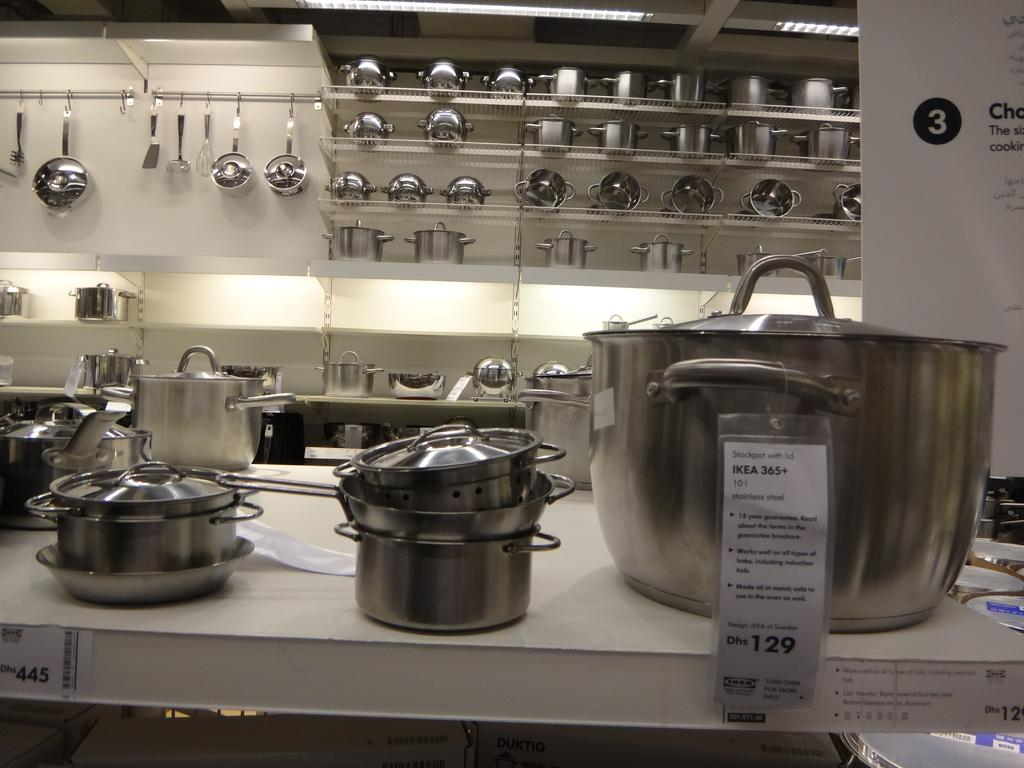Provide a one-sentence caption for the provided image. The new pots and pans are on display for sale at Ikea. 